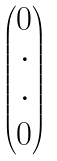<formula> <loc_0><loc_0><loc_500><loc_500>\begin{pmatrix} 0 \\ \cdot \\ \cdot \\ 0 \end{pmatrix}</formula> 